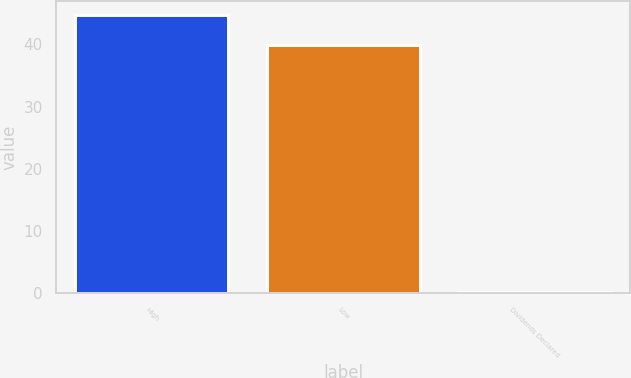Convert chart to OTSL. <chart><loc_0><loc_0><loc_500><loc_500><bar_chart><fcel>High<fcel>Low<fcel>Dividends Declared<nl><fcel>44.77<fcel>39.85<fcel>0.21<nl></chart> 